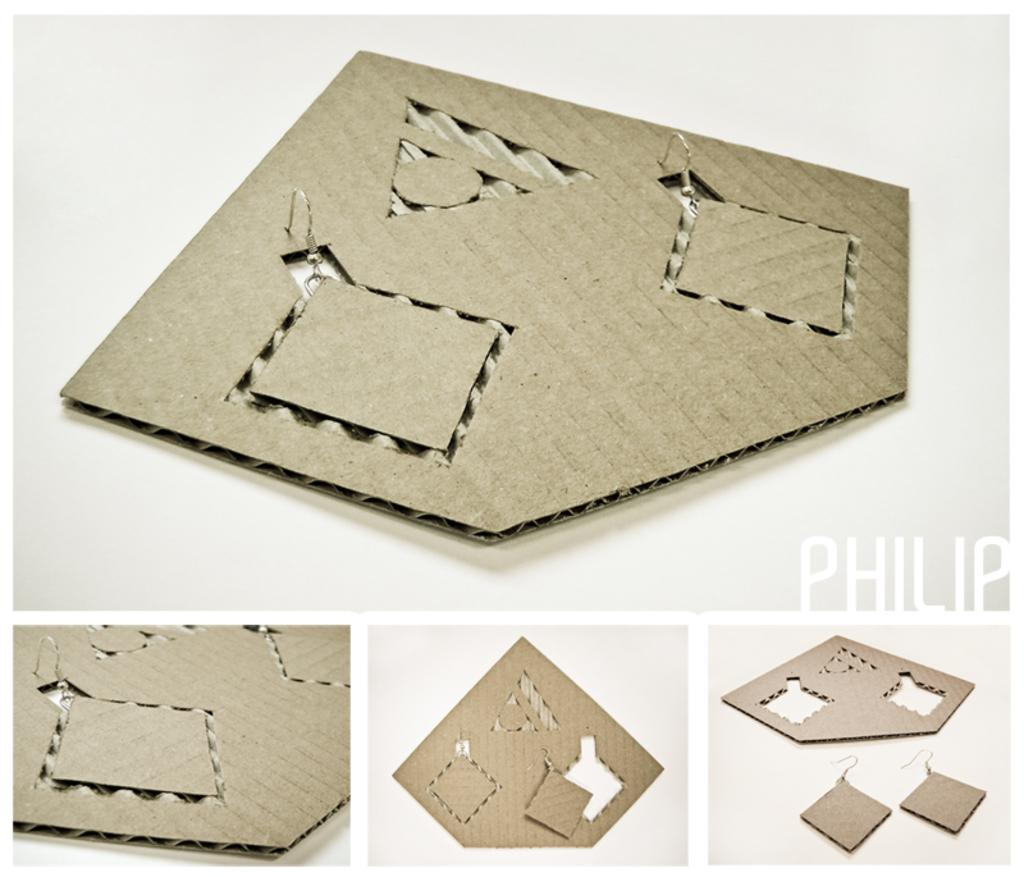What type of image is being described? The image is a collage of a cardboard craft. Can you identify any specific features or elements in the image? There is a watermark on the right side of the image. What color is the background of the image? The background of the image is white. What type of bun is being used to hold the receipt in the image? There is no bun or receipt present in the image; it is a collage of a cardboard craft with a watermark on the right side and a white background. 